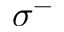<formula> <loc_0><loc_0><loc_500><loc_500>\sigma ^ { - }</formula> 